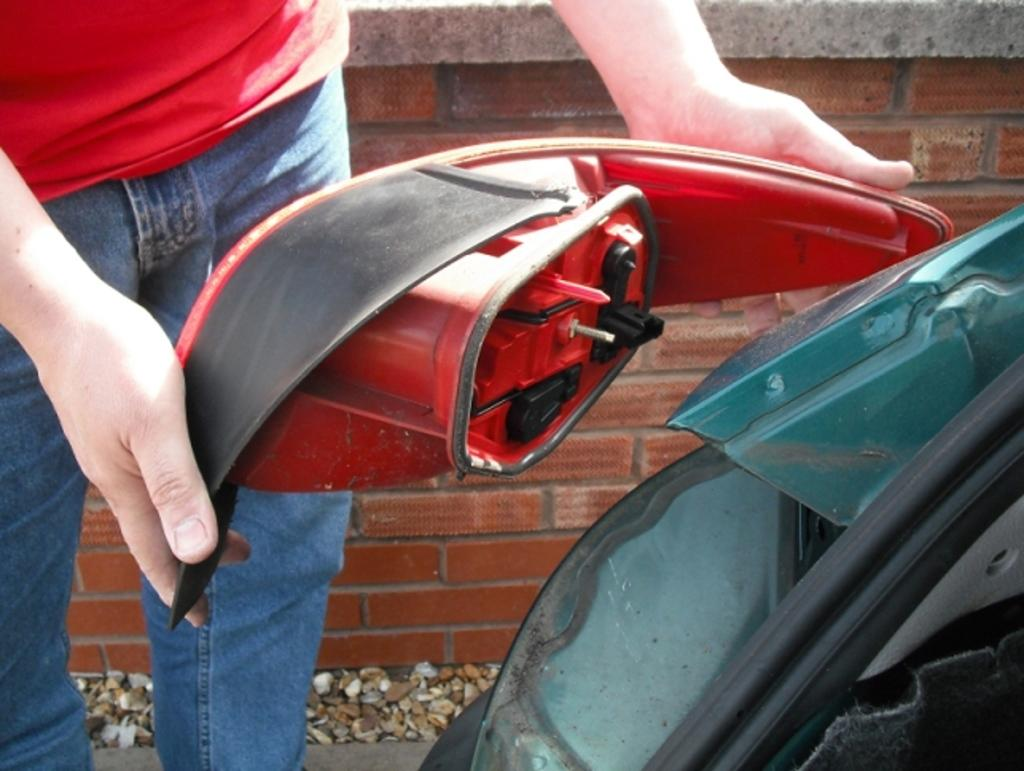Who is present in the image? There is a man in the image. What is the man holding in the image? The man is holding a light. What can be seen on the right side of the image? There appears to be a vehicle on the right side of the image. What is visible in the background of the image? There is a wall in the background of the image. What is visible at the bottom of the image? The ground is visible at the bottom of the image. What is the man's position in the competition in the image? There is no competition present in the image, so it is not possible to determine the man's position in a competition. 